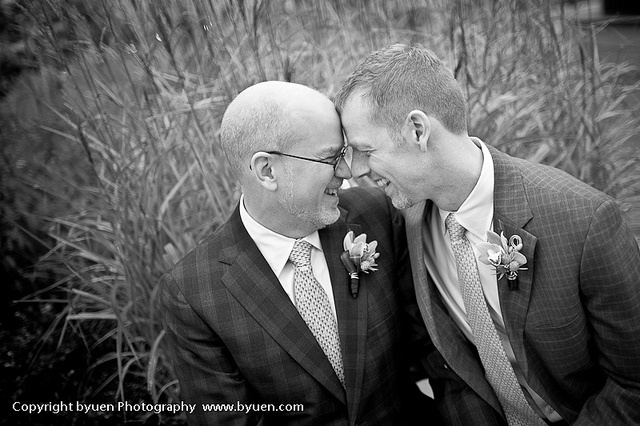Describe the objects in this image and their specific colors. I can see people in black, darkgray, gray, and lightgray tones, people in black, gray, darkgray, and lightgray tones, tie in black, darkgray, gray, and lightgray tones, and tie in black, lightgray, darkgray, and gray tones in this image. 